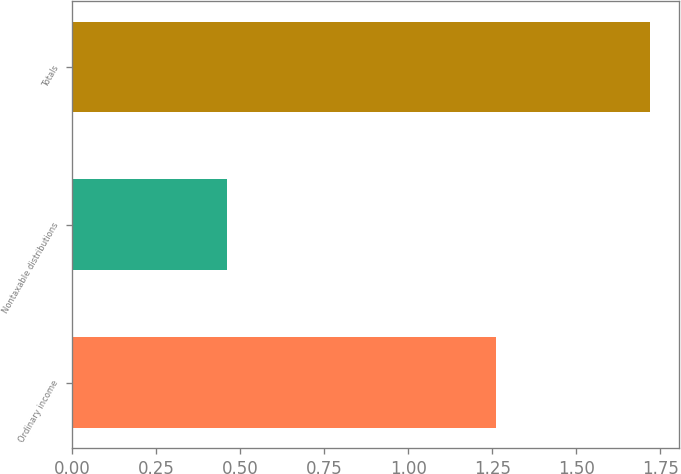Convert chart to OTSL. <chart><loc_0><loc_0><loc_500><loc_500><bar_chart><fcel>Ordinary income<fcel>Nontaxable distributions<fcel>Totals<nl><fcel>1.26<fcel>0.46<fcel>1.72<nl></chart> 